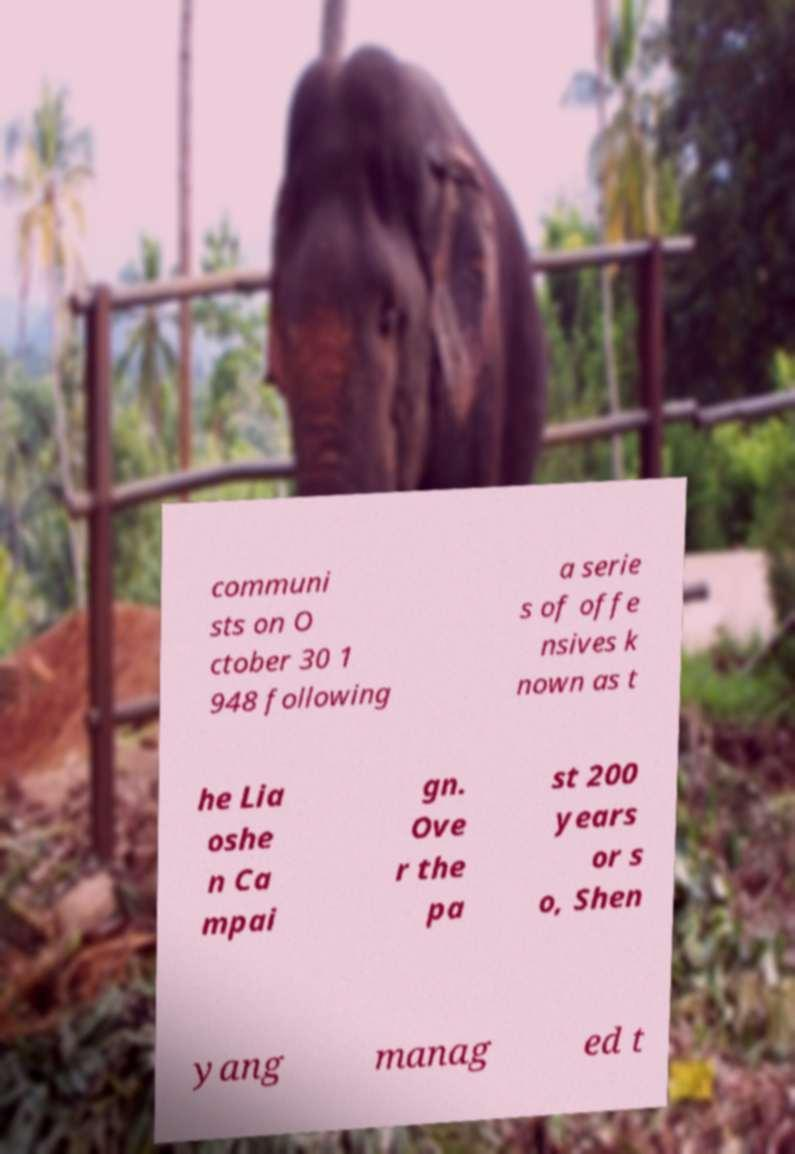What messages or text are displayed in this image? I need them in a readable, typed format. communi sts on O ctober 30 1 948 following a serie s of offe nsives k nown as t he Lia oshe n Ca mpai gn. Ove r the pa st 200 years or s o, Shen yang manag ed t 